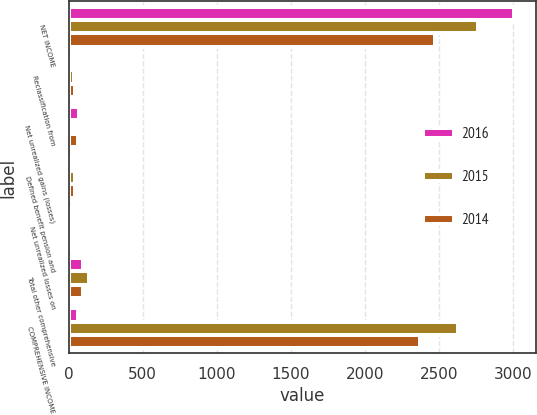<chart> <loc_0><loc_0><loc_500><loc_500><stacked_bar_chart><ecel><fcel>NET INCOME<fcel>Reclassification from<fcel>Net unrealized gains (losses)<fcel>Defined benefit pension and<fcel>Net unrealized losses on<fcel>Total other comprehensive<fcel>COMPREHENSIVE INCOME<nl><fcel>2016<fcel>3005<fcel>18<fcel>69<fcel>21<fcel>5<fcel>97<fcel>63<nl><fcel>2015<fcel>2762<fcel>37<fcel>7<fcel>42<fcel>27<fcel>138<fcel>2624<nl><fcel>2014<fcel>2469<fcel>41<fcel>62<fcel>43<fcel>25<fcel>98<fcel>2371<nl></chart> 